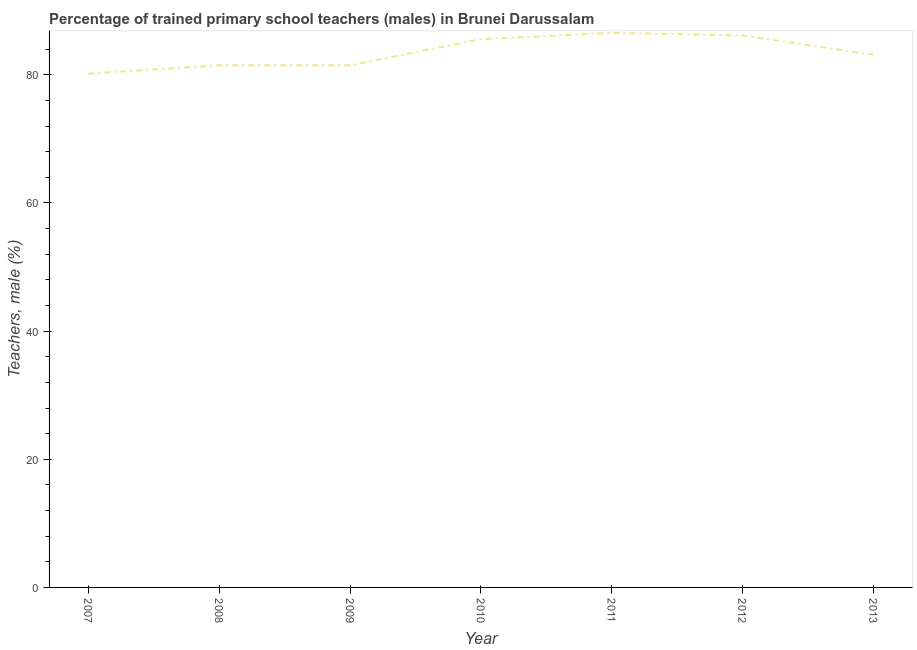What is the percentage of trained male teachers in 2012?
Offer a terse response. 86.13. Across all years, what is the maximum percentage of trained male teachers?
Make the answer very short. 86.54. Across all years, what is the minimum percentage of trained male teachers?
Your response must be concise. 80.18. What is the sum of the percentage of trained male teachers?
Your answer should be compact. 584.55. What is the difference between the percentage of trained male teachers in 2009 and 2010?
Provide a succinct answer. -4.08. What is the average percentage of trained male teachers per year?
Ensure brevity in your answer.  83.51. What is the median percentage of trained male teachers?
Your response must be concise. 83.16. What is the ratio of the percentage of trained male teachers in 2009 to that in 2012?
Offer a terse response. 0.95. Is the percentage of trained male teachers in 2008 less than that in 2013?
Give a very brief answer. Yes. Is the difference between the percentage of trained male teachers in 2007 and 2013 greater than the difference between any two years?
Make the answer very short. No. What is the difference between the highest and the second highest percentage of trained male teachers?
Offer a very short reply. 0.41. Is the sum of the percentage of trained male teachers in 2007 and 2010 greater than the maximum percentage of trained male teachers across all years?
Offer a terse response. Yes. What is the difference between the highest and the lowest percentage of trained male teachers?
Offer a terse response. 6.36. How many lines are there?
Give a very brief answer. 1. Are the values on the major ticks of Y-axis written in scientific E-notation?
Offer a very short reply. No. Does the graph contain any zero values?
Make the answer very short. No. Does the graph contain grids?
Ensure brevity in your answer.  No. What is the title of the graph?
Offer a very short reply. Percentage of trained primary school teachers (males) in Brunei Darussalam. What is the label or title of the Y-axis?
Make the answer very short. Teachers, male (%). What is the Teachers, male (%) in 2007?
Keep it short and to the point. 80.18. What is the Teachers, male (%) in 2008?
Ensure brevity in your answer.  81.49. What is the Teachers, male (%) in 2009?
Provide a short and direct response. 81.49. What is the Teachers, male (%) of 2010?
Your answer should be very brief. 85.56. What is the Teachers, male (%) of 2011?
Give a very brief answer. 86.54. What is the Teachers, male (%) in 2012?
Ensure brevity in your answer.  86.13. What is the Teachers, male (%) in 2013?
Your answer should be very brief. 83.16. What is the difference between the Teachers, male (%) in 2007 and 2008?
Make the answer very short. -1.31. What is the difference between the Teachers, male (%) in 2007 and 2009?
Provide a short and direct response. -1.31. What is the difference between the Teachers, male (%) in 2007 and 2010?
Your answer should be compact. -5.39. What is the difference between the Teachers, male (%) in 2007 and 2011?
Provide a short and direct response. -6.36. What is the difference between the Teachers, male (%) in 2007 and 2012?
Give a very brief answer. -5.96. What is the difference between the Teachers, male (%) in 2007 and 2013?
Keep it short and to the point. -2.98. What is the difference between the Teachers, male (%) in 2008 and 2009?
Give a very brief answer. -0. What is the difference between the Teachers, male (%) in 2008 and 2010?
Give a very brief answer. -4.08. What is the difference between the Teachers, male (%) in 2008 and 2011?
Give a very brief answer. -5.06. What is the difference between the Teachers, male (%) in 2008 and 2012?
Your response must be concise. -4.65. What is the difference between the Teachers, male (%) in 2008 and 2013?
Offer a very short reply. -1.67. What is the difference between the Teachers, male (%) in 2009 and 2010?
Your answer should be compact. -4.08. What is the difference between the Teachers, male (%) in 2009 and 2011?
Ensure brevity in your answer.  -5.06. What is the difference between the Teachers, male (%) in 2009 and 2012?
Make the answer very short. -4.65. What is the difference between the Teachers, male (%) in 2009 and 2013?
Keep it short and to the point. -1.67. What is the difference between the Teachers, male (%) in 2010 and 2011?
Provide a succinct answer. -0.98. What is the difference between the Teachers, male (%) in 2010 and 2012?
Provide a short and direct response. -0.57. What is the difference between the Teachers, male (%) in 2010 and 2013?
Your response must be concise. 2.41. What is the difference between the Teachers, male (%) in 2011 and 2012?
Your answer should be compact. 0.41. What is the difference between the Teachers, male (%) in 2011 and 2013?
Your response must be concise. 3.39. What is the difference between the Teachers, male (%) in 2012 and 2013?
Offer a very short reply. 2.98. What is the ratio of the Teachers, male (%) in 2007 to that in 2008?
Keep it short and to the point. 0.98. What is the ratio of the Teachers, male (%) in 2007 to that in 2009?
Keep it short and to the point. 0.98. What is the ratio of the Teachers, male (%) in 2007 to that in 2010?
Ensure brevity in your answer.  0.94. What is the ratio of the Teachers, male (%) in 2007 to that in 2011?
Provide a succinct answer. 0.93. What is the ratio of the Teachers, male (%) in 2007 to that in 2012?
Provide a succinct answer. 0.93. What is the ratio of the Teachers, male (%) in 2007 to that in 2013?
Your answer should be very brief. 0.96. What is the ratio of the Teachers, male (%) in 2008 to that in 2009?
Your answer should be very brief. 1. What is the ratio of the Teachers, male (%) in 2008 to that in 2010?
Your answer should be compact. 0.95. What is the ratio of the Teachers, male (%) in 2008 to that in 2011?
Offer a very short reply. 0.94. What is the ratio of the Teachers, male (%) in 2008 to that in 2012?
Offer a very short reply. 0.95. What is the ratio of the Teachers, male (%) in 2008 to that in 2013?
Make the answer very short. 0.98. What is the ratio of the Teachers, male (%) in 2009 to that in 2011?
Offer a terse response. 0.94. What is the ratio of the Teachers, male (%) in 2009 to that in 2012?
Keep it short and to the point. 0.95. What is the ratio of the Teachers, male (%) in 2010 to that in 2011?
Keep it short and to the point. 0.99. What is the ratio of the Teachers, male (%) in 2010 to that in 2012?
Offer a very short reply. 0.99. What is the ratio of the Teachers, male (%) in 2010 to that in 2013?
Keep it short and to the point. 1.03. What is the ratio of the Teachers, male (%) in 2011 to that in 2012?
Offer a terse response. 1. What is the ratio of the Teachers, male (%) in 2011 to that in 2013?
Give a very brief answer. 1.04. What is the ratio of the Teachers, male (%) in 2012 to that in 2013?
Provide a short and direct response. 1.04. 